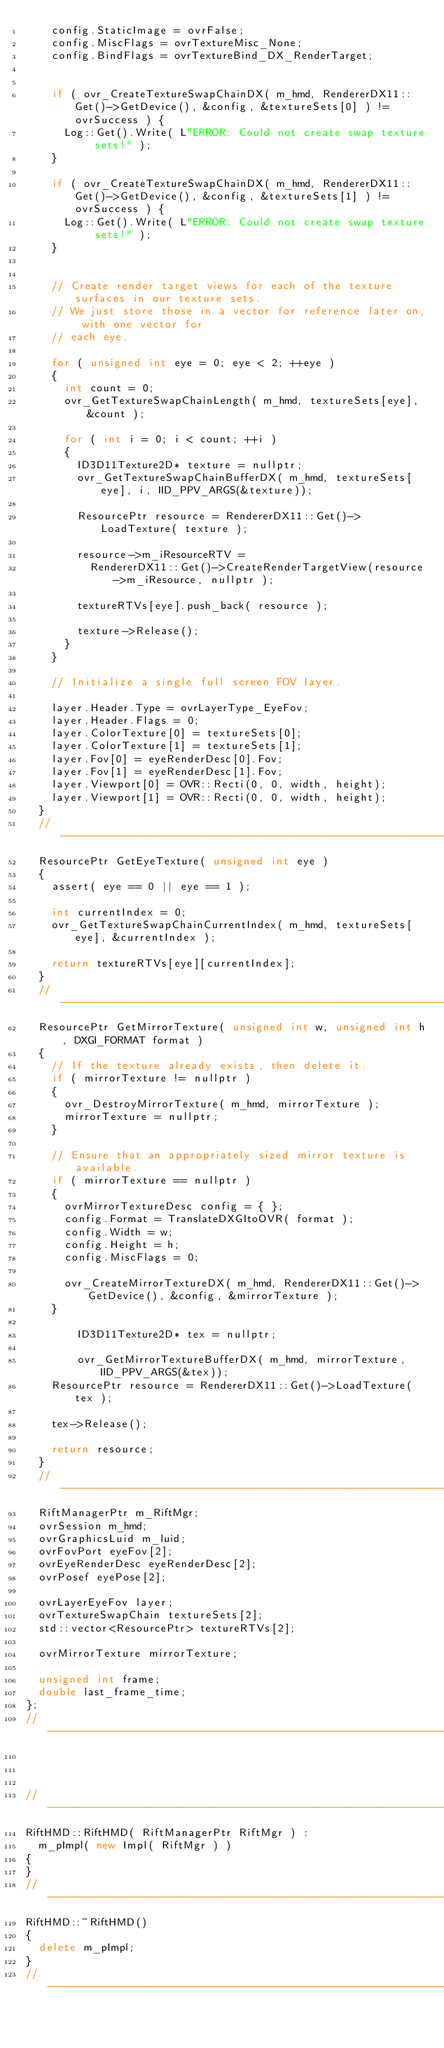Convert code to text. <code><loc_0><loc_0><loc_500><loc_500><_C++_>		config.StaticImage = ovrFalse;
		config.MiscFlags = ovrTextureMisc_None;
		config.BindFlags = ovrTextureBind_DX_RenderTarget;

		
		if ( ovr_CreateTextureSwapChainDX( m_hmd, RendererDX11::Get()->GetDevice(), &config, &textureSets[0] ) != ovrSuccess ) {
			Log::Get().Write( L"ERROR: Could not create swap texture sets!" );
		}

		if ( ovr_CreateTextureSwapChainDX( m_hmd, RendererDX11::Get()->GetDevice(), &config, &textureSets[1] ) != ovrSuccess ) {
			Log::Get().Write( L"ERROR: Could not create swap texture sets!" );
		}


		// Create render target views for each of the texture surfaces in our texture sets.
		// We just store those in a vector for reference later on, with one vector for
		// each eye.
		
		for ( unsigned int eye = 0; eye < 2; ++eye )
		{
			int count = 0;
			ovr_GetTextureSwapChainLength( m_hmd, textureSets[eye], &count );

			for ( int i = 0; i < count; ++i )
			{
				ID3D11Texture2D* texture = nullptr;
				ovr_GetTextureSwapChainBufferDX( m_hmd, textureSets[eye], i, IID_PPV_ARGS(&texture));
				
				ResourcePtr resource = RendererDX11::Get()->LoadTexture( texture );

				resource->m_iResourceRTV = 
					RendererDX11::Get()->CreateRenderTargetView(resource->m_iResource, nullptr );

				textureRTVs[eye].push_back( resource );

				texture->Release(); 
			}
		}

		// Initialize a single full screen FOV layer.
		
		layer.Header.Type = ovrLayerType_EyeFov;
		layer.Header.Flags = 0;
		layer.ColorTexture[0] = textureSets[0];
		layer.ColorTexture[1] = textureSets[1];
		layer.Fov[0] = eyeRenderDesc[0].Fov;
		layer.Fov[1] = eyeRenderDesc[1].Fov;
		layer.Viewport[0] = OVR::Recti(0, 0, width, height);
		layer.Viewport[1] = OVR::Recti(0, 0, width, height);
	}
	//--------------------------------------------------------------------------------
	ResourcePtr GetEyeTexture( unsigned int eye )
	{
		assert( eye == 0 || eye == 1 );

		int currentIndex = 0;
		ovr_GetTextureSwapChainCurrentIndex( m_hmd, textureSets[eye], &currentIndex );

		return textureRTVs[eye][currentIndex];
	}
	//--------------------------------------------------------------------------------
	ResourcePtr GetMirrorTexture( unsigned int w, unsigned int h, DXGI_FORMAT format )
	{
		// If the texture already exists, then delete it.
		if ( mirrorTexture != nullptr )
		{
			ovr_DestroyMirrorTexture( m_hmd, mirrorTexture );
			mirrorTexture = nullptr;
		}

		// Ensure that an appropriately sized mirror texture is available.
		if ( mirrorTexture == nullptr )
		{
			ovrMirrorTextureDesc config = { };
			config.Format = TranslateDXGItoOVR( format );
			config.Width = w;
			config.Height = h;
			config.MiscFlags = 0;

			ovr_CreateMirrorTextureDX( m_hmd, RendererDX11::Get()->GetDevice(), &config, &mirrorTexture );
		}

        ID3D11Texture2D* tex = nullptr;

        ovr_GetMirrorTextureBufferDX( m_hmd, mirrorTexture, IID_PPV_ARGS(&tex));
		ResourcePtr resource = RendererDX11::Get()->LoadTexture( tex );

		tex->Release();

		return resource;
	}
	//--------------------------------------------------------------------------------
	RiftManagerPtr m_RiftMgr;
	ovrSession m_hmd;
	ovrGraphicsLuid m_luid;
	ovrFovPort eyeFov[2];
	ovrEyeRenderDesc eyeRenderDesc[2];
	ovrPosef eyePose[2];
	
	ovrLayerEyeFov layer;
	ovrTextureSwapChain textureSets[2];
	std::vector<ResourcePtr> textureRTVs[2];
	
	ovrMirrorTexture mirrorTexture;

	unsigned int frame;
	double last_frame_time;
};
//--------------------------------------------------------------------------------



//--------------------------------------------------------------------------------
RiftHMD::RiftHMD( RiftManagerPtr RiftMgr ) : 
	m_pImpl( new Impl( RiftMgr ) )	
{
}
//--------------------------------------------------------------------------------
RiftHMD::~RiftHMD()
{
	delete m_pImpl;
}
//--------------------------------------------------------------------------------</code> 